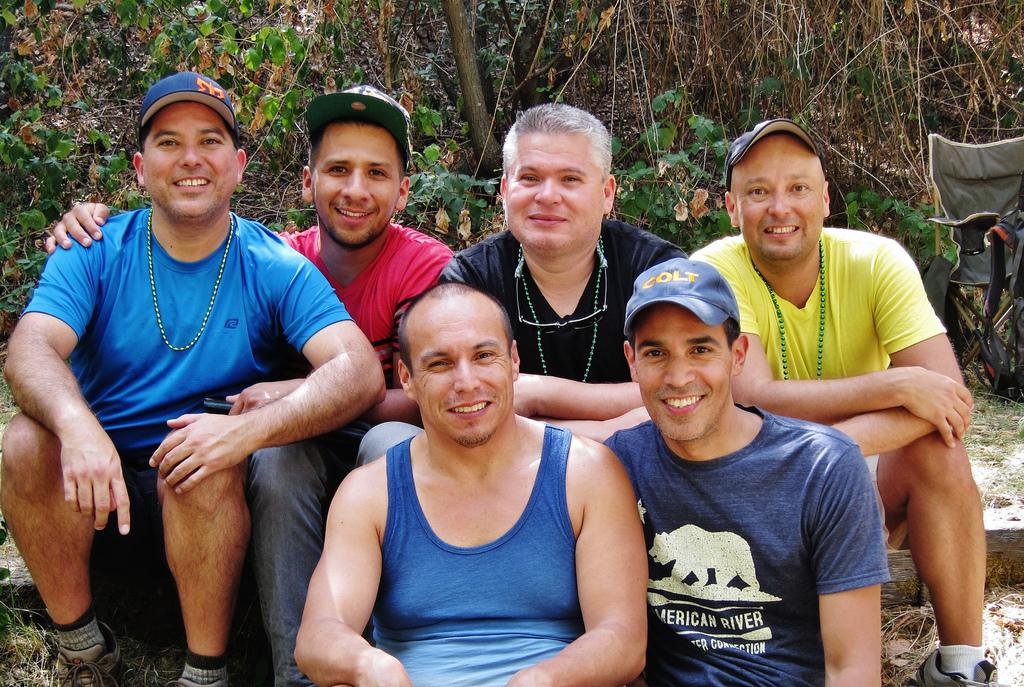How many people are sitting on the fence in the foreground? There are six persons sitting on the fence in the foreground. What can be seen in the background of the image? There are trees visible in the background. When was the image taken? The image was taken during the day. What type of can is visible in the image? There is no can present in the image. Is there any spy equipment visible in the image? There is no spy equipment present in the image. 